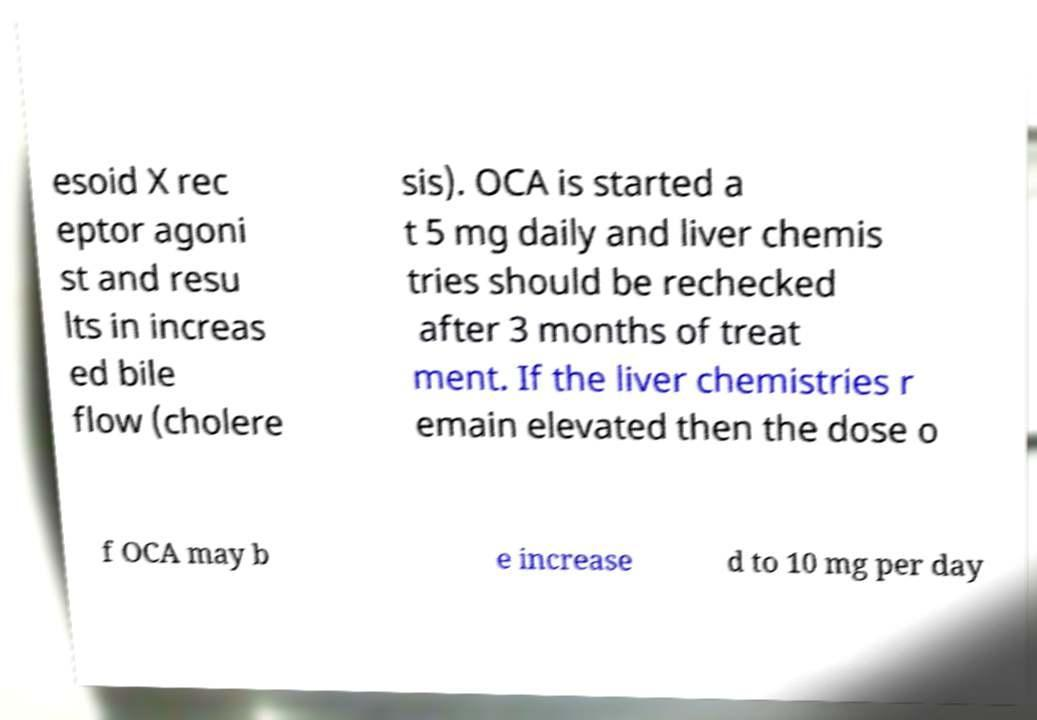For documentation purposes, I need the text within this image transcribed. Could you provide that? esoid X rec eptor agoni st and resu lts in increas ed bile flow (cholere sis). OCA is started a t 5 mg daily and liver chemis tries should be rechecked after 3 months of treat ment. If the liver chemistries r emain elevated then the dose o f OCA may b e increase d to 10 mg per day 